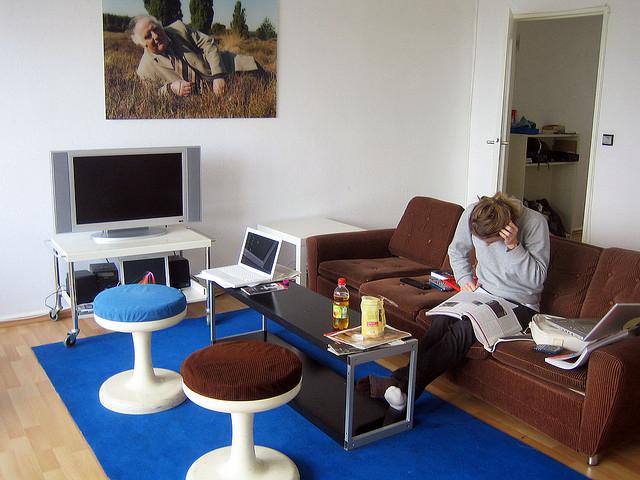What colors are the tops of the stools?
Short answer required. Blue and brown. Is there a laptop on the table?
Keep it brief. Yes. Is the man reading?
Answer briefly. Yes. 